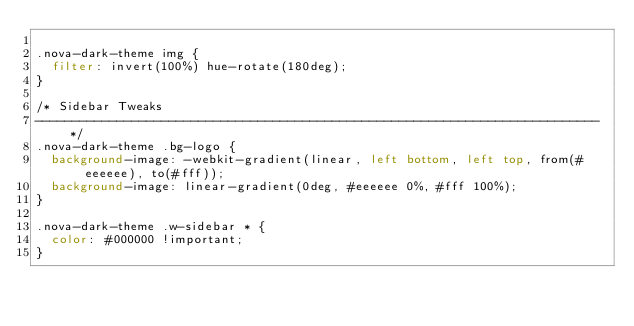<code> <loc_0><loc_0><loc_500><loc_500><_CSS_>
.nova-dark-theme img {
  filter: invert(100%) hue-rotate(180deg);
}

/* Sidebar Tweaks
---------------------------------------------------------------------------- */
.nova-dark-theme .bg-logo {
  background-image: -webkit-gradient(linear, left bottom, left top, from(#eeeeee), to(#fff));
  background-image: linear-gradient(0deg, #eeeeee 0%, #fff 100%);
}

.nova-dark-theme .w-sidebar * {
  color: #000000 !important;
}
</code> 